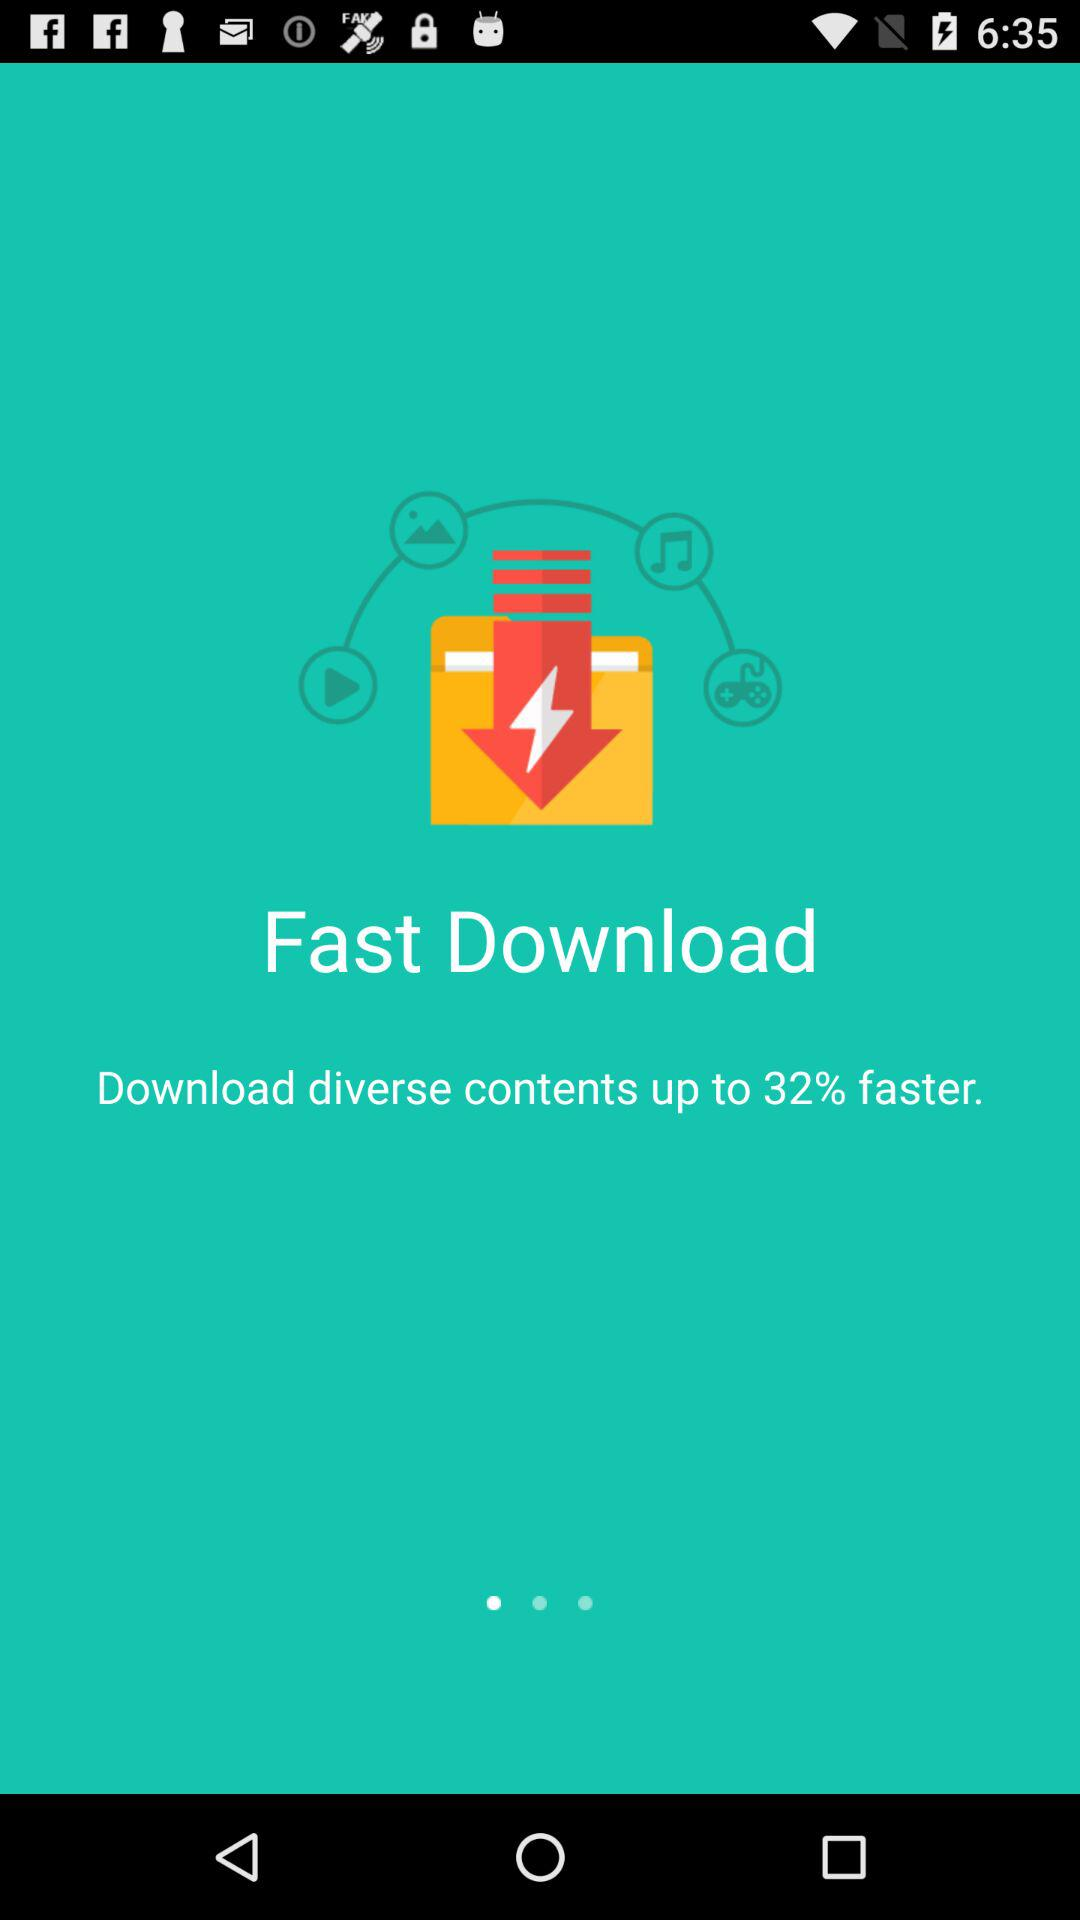How many percent faster does the app claim to download diverse contents than regular downloads?
Answer the question using a single word or phrase. 32% 